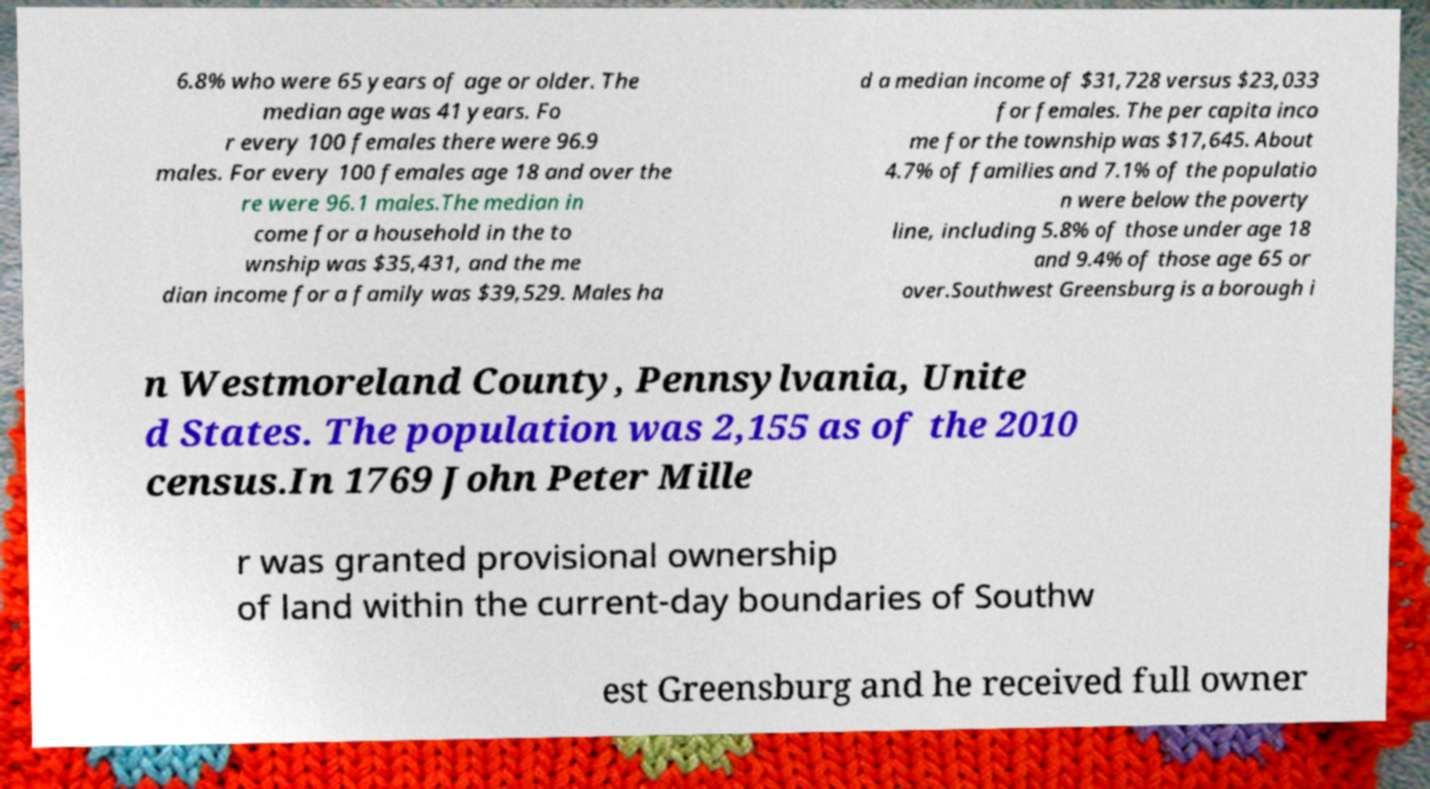There's text embedded in this image that I need extracted. Can you transcribe it verbatim? 6.8% who were 65 years of age or older. The median age was 41 years. Fo r every 100 females there were 96.9 males. For every 100 females age 18 and over the re were 96.1 males.The median in come for a household in the to wnship was $35,431, and the me dian income for a family was $39,529. Males ha d a median income of $31,728 versus $23,033 for females. The per capita inco me for the township was $17,645. About 4.7% of families and 7.1% of the populatio n were below the poverty line, including 5.8% of those under age 18 and 9.4% of those age 65 or over.Southwest Greensburg is a borough i n Westmoreland County, Pennsylvania, Unite d States. The population was 2,155 as of the 2010 census.In 1769 John Peter Mille r was granted provisional ownership of land within the current-day boundaries of Southw est Greensburg and he received full owner 